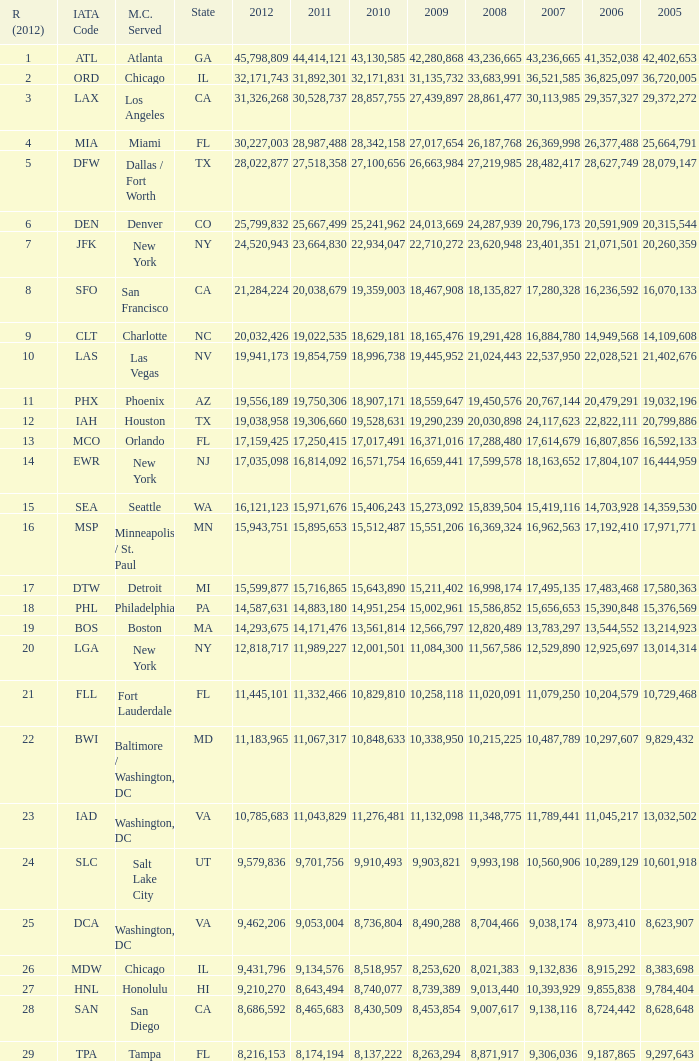What is the greatest 2010 for Miami, Fl? 28342158.0. 